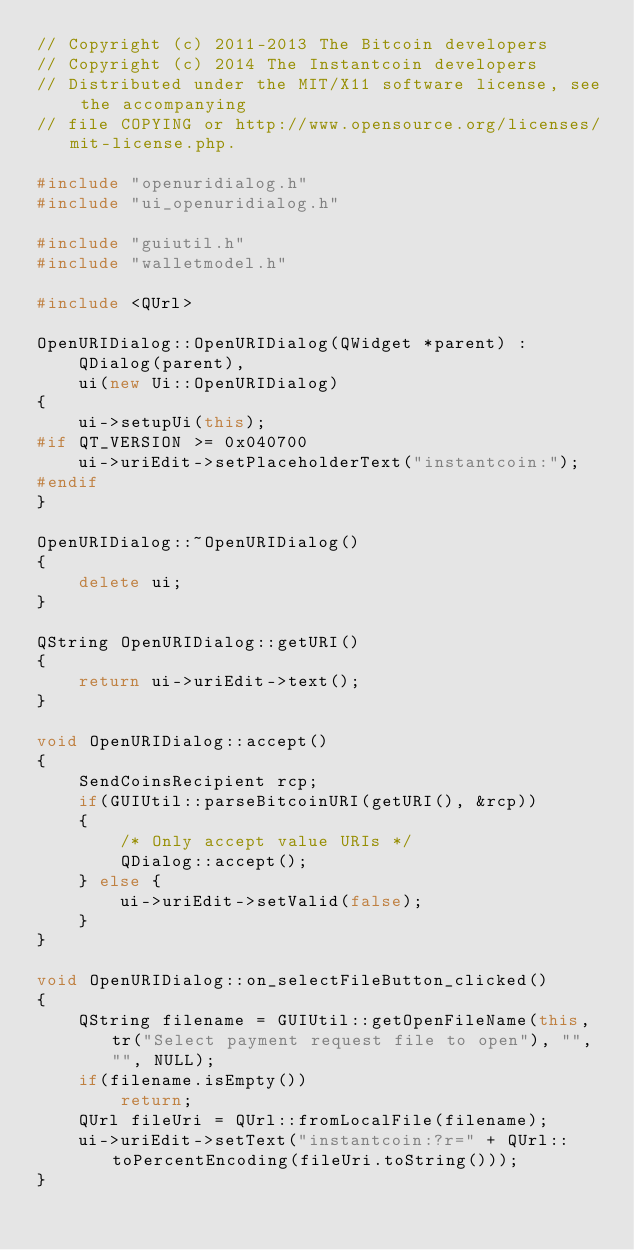<code> <loc_0><loc_0><loc_500><loc_500><_C++_>// Copyright (c) 2011-2013 The Bitcoin developers
// Copyright (c) 2014 The Instantcoin developers
// Distributed under the MIT/X11 software license, see the accompanying
// file COPYING or http://www.opensource.org/licenses/mit-license.php.

#include "openuridialog.h"
#include "ui_openuridialog.h"

#include "guiutil.h"
#include "walletmodel.h"

#include <QUrl>

OpenURIDialog::OpenURIDialog(QWidget *parent) :
    QDialog(parent),
    ui(new Ui::OpenURIDialog)
{
    ui->setupUi(this);
#if QT_VERSION >= 0x040700
    ui->uriEdit->setPlaceholderText("instantcoin:");
#endif
}

OpenURIDialog::~OpenURIDialog()
{
    delete ui;
}

QString OpenURIDialog::getURI()
{
    return ui->uriEdit->text();
}

void OpenURIDialog::accept()
{
    SendCoinsRecipient rcp;
    if(GUIUtil::parseBitcoinURI(getURI(), &rcp))
    {
        /* Only accept value URIs */
        QDialog::accept();
    } else {
        ui->uriEdit->setValid(false);
    }
}

void OpenURIDialog::on_selectFileButton_clicked()
{
    QString filename = GUIUtil::getOpenFileName(this, tr("Select payment request file to open"), "", "", NULL);
    if(filename.isEmpty())
        return;
    QUrl fileUri = QUrl::fromLocalFile(filename);
    ui->uriEdit->setText("instantcoin:?r=" + QUrl::toPercentEncoding(fileUri.toString()));
}
</code> 